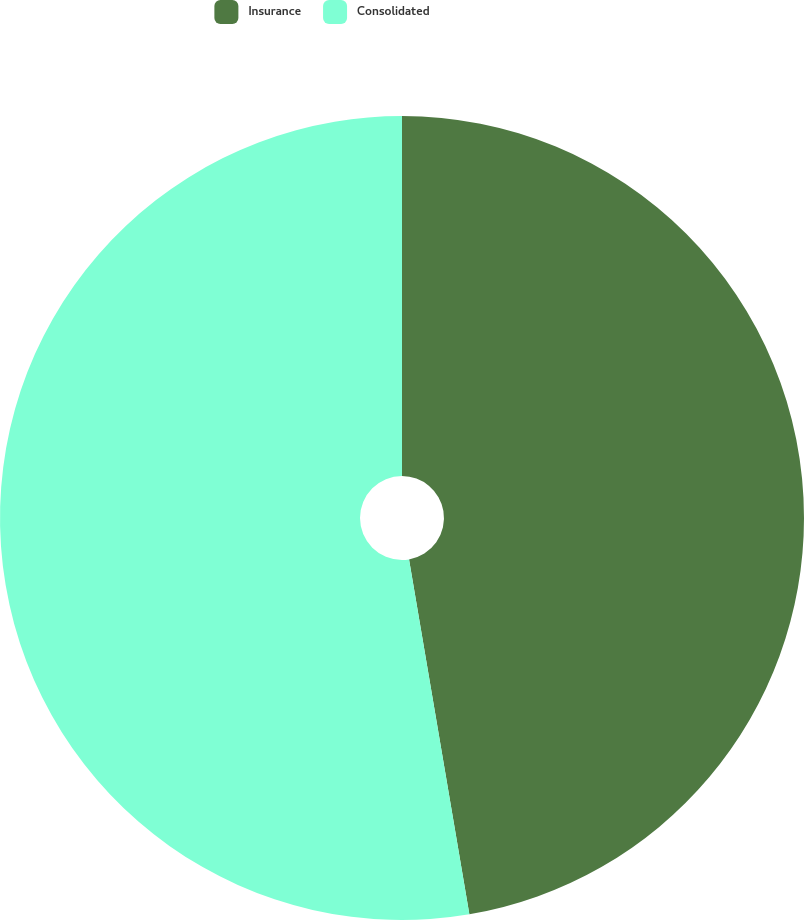Convert chart. <chart><loc_0><loc_0><loc_500><loc_500><pie_chart><fcel>Insurance<fcel>Consolidated<nl><fcel>47.32%<fcel>52.68%<nl></chart> 